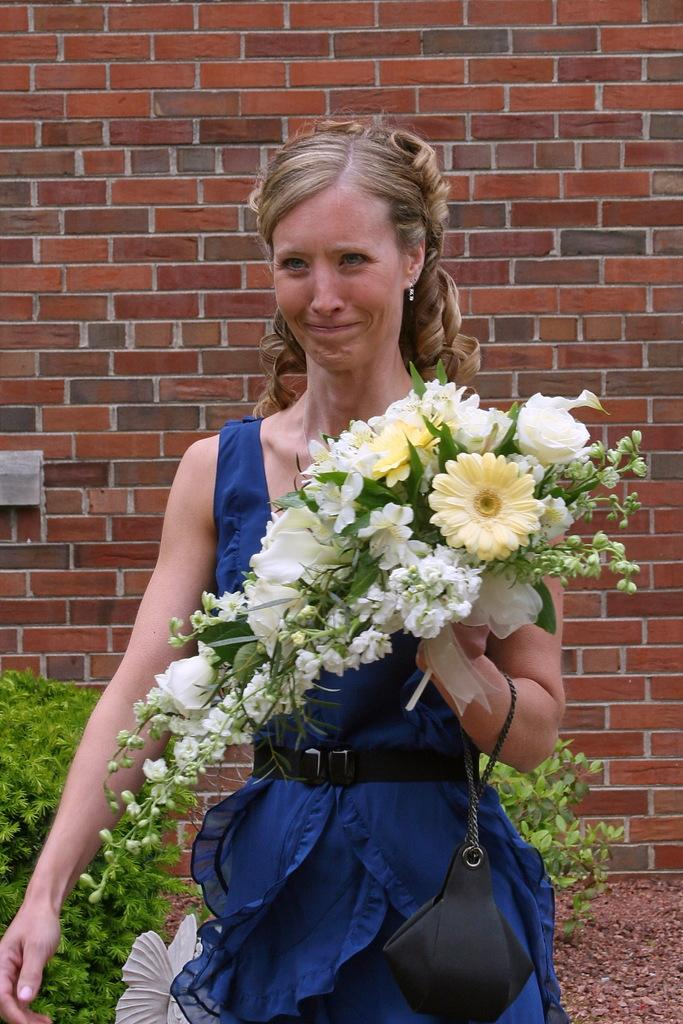Who is present in the image? There is a person in the image. What is the person wearing? The person is wearing a blue dress. What is the person holding in her hand? The person is holding flowers in her hand. What can be seen at the bottom of the image? There are bushes at the bottom of the image. What type of bell can be heard ringing in the image? There is no bell present or ringing in the image. Is the person in the image a doctor? The provided facts do not mention the person's profession, so we cannot determine if they are a doctor. 